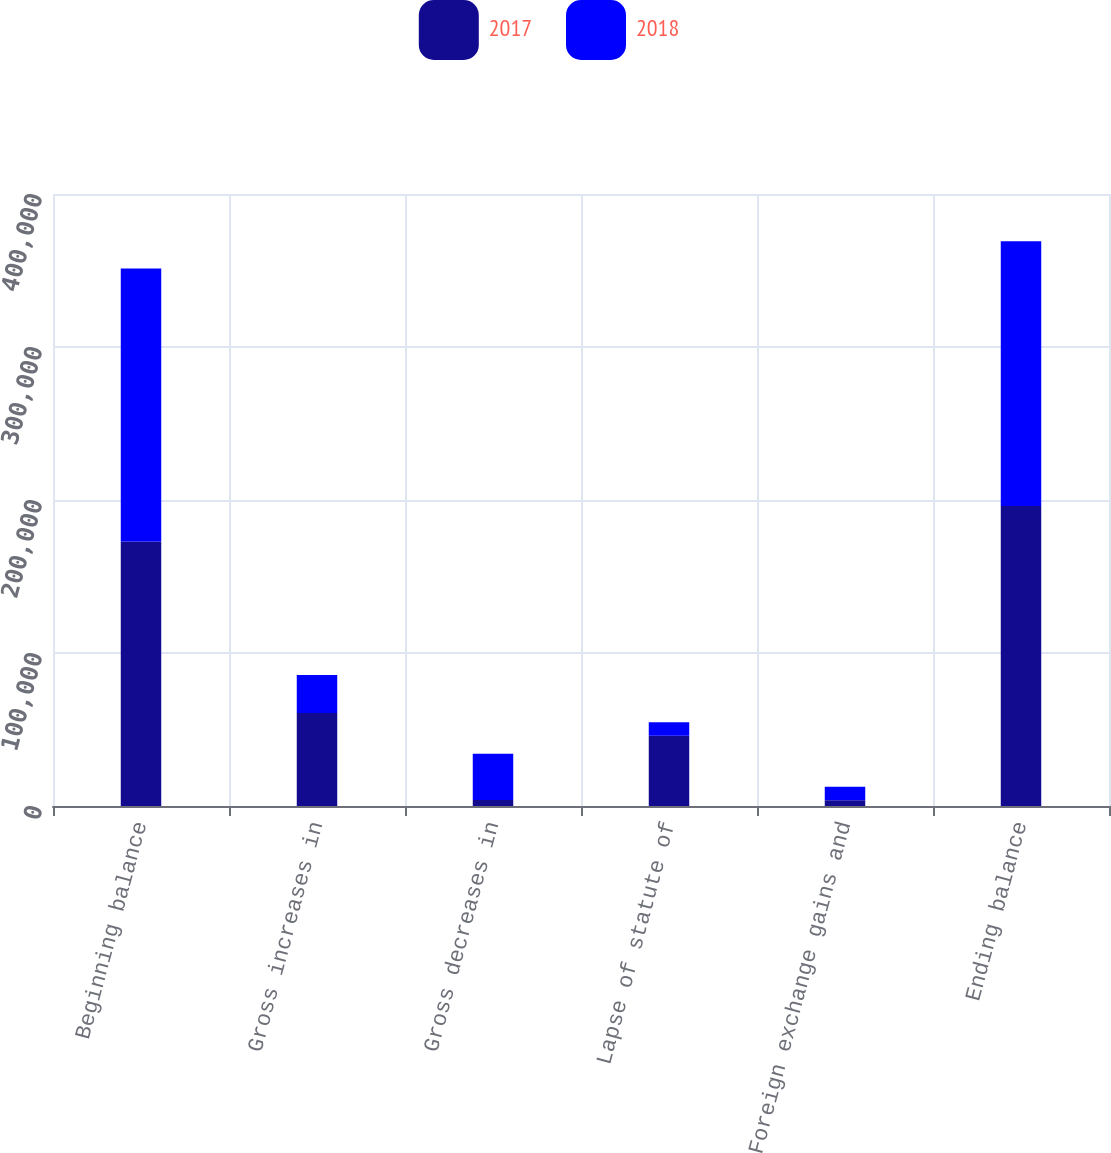Convert chart to OTSL. <chart><loc_0><loc_0><loc_500><loc_500><stacked_bar_chart><ecel><fcel>Beginning balance<fcel>Gross increases in<fcel>Gross decreases in<fcel>Lapse of statute of<fcel>Foreign exchange gains and<fcel>Ending balance<nl><fcel>2017<fcel>172945<fcel>60721<fcel>4000<fcel>45922<fcel>3783<fcel>196152<nl><fcel>2018<fcel>178413<fcel>24927<fcel>30166<fcel>8819<fcel>8786<fcel>172945<nl></chart> 